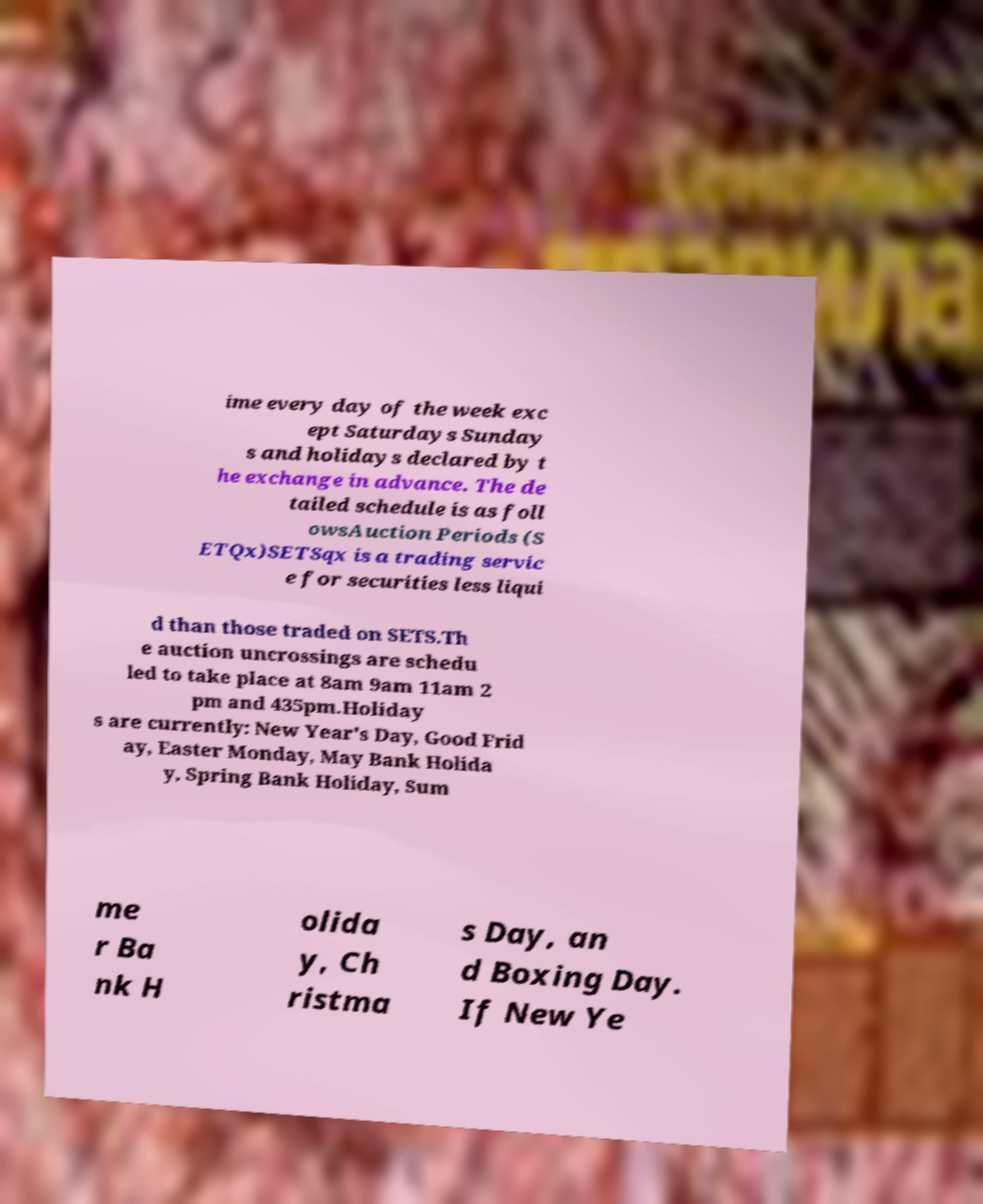Can you accurately transcribe the text from the provided image for me? ime every day of the week exc ept Saturdays Sunday s and holidays declared by t he exchange in advance. The de tailed schedule is as foll owsAuction Periods (S ETQx)SETSqx is a trading servic e for securities less liqui d than those traded on SETS.Th e auction uncrossings are schedu led to take place at 8am 9am 11am 2 pm and 435pm.Holiday s are currently: New Year's Day, Good Frid ay, Easter Monday, May Bank Holida y, Spring Bank Holiday, Sum me r Ba nk H olida y, Ch ristma s Day, an d Boxing Day. If New Ye 